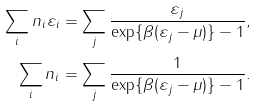<formula> <loc_0><loc_0><loc_500><loc_500>\sum _ { i } n _ { i } \varepsilon _ { i } & = \sum _ { j } \frac { \varepsilon _ { j } } { \exp \{ \beta ( \varepsilon _ { j } - \mu ) \} - 1 } , \\ \sum _ { i } n _ { i } & = \sum _ { j } \frac { 1 } { \exp \{ \beta ( \varepsilon _ { j } - \mu ) \} - 1 } .</formula> 